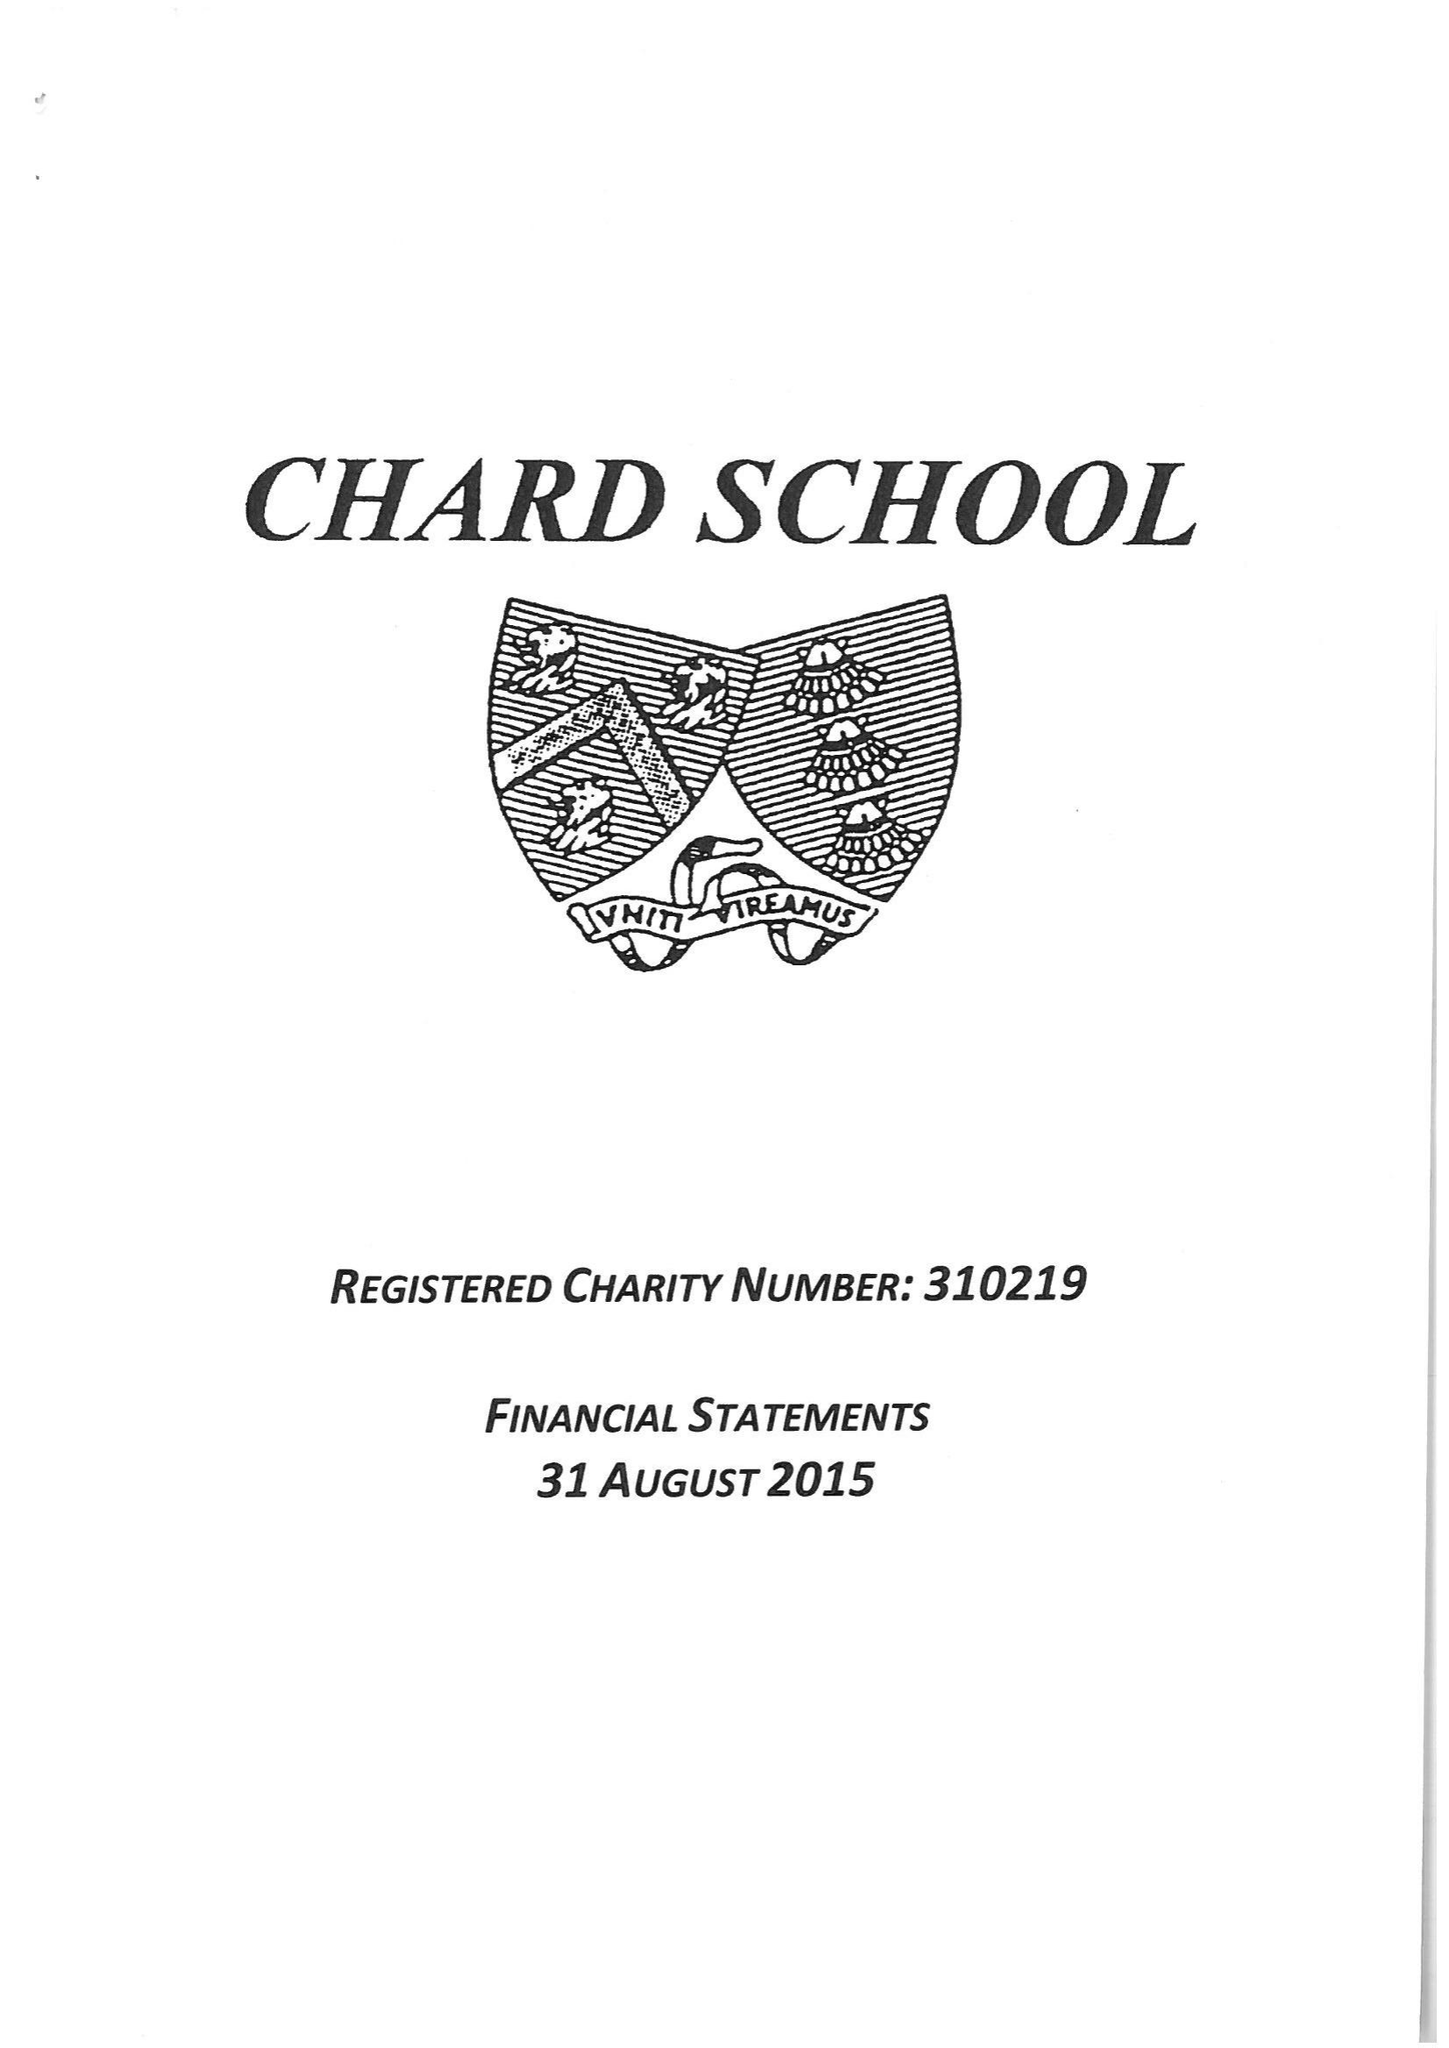What is the value for the address__post_town?
Answer the question using a single word or phrase. CHARD 